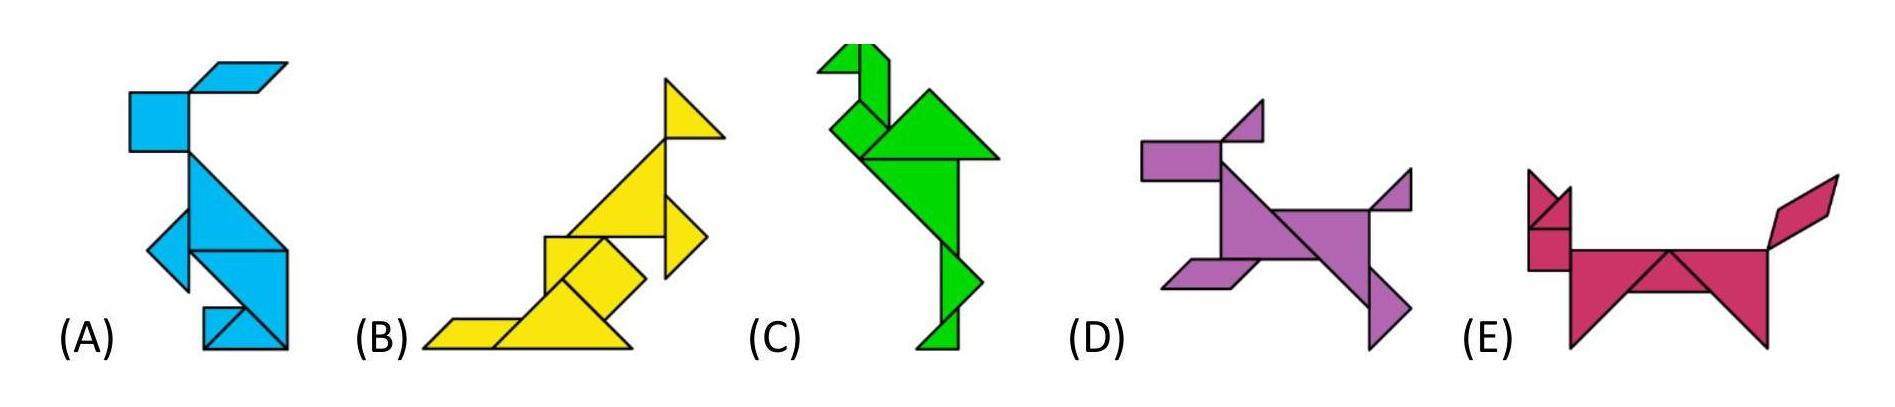What could the use of different colors signify for these animals? The distinct color of each animal might imply individual traits or denote different habitats and behaviors. Blue, associated with water, could suggest that animal A is aquatic or linked to such environments. Yellow often symbolizes energy and vibrance, which fits the active posture of animal B. Green can represent life and nature, which is suitable for animal C, resembling a deer or an elk that is commonly found in forested areas. The purple color of animal D could symbolize uniqueness or creativity, fitting for the animal that contains a shape not found in others. Lastly, the color red, used for animal E, might denote passion or strength, aligning with the sturdy, strong posture of this animal, possibly a bull. 